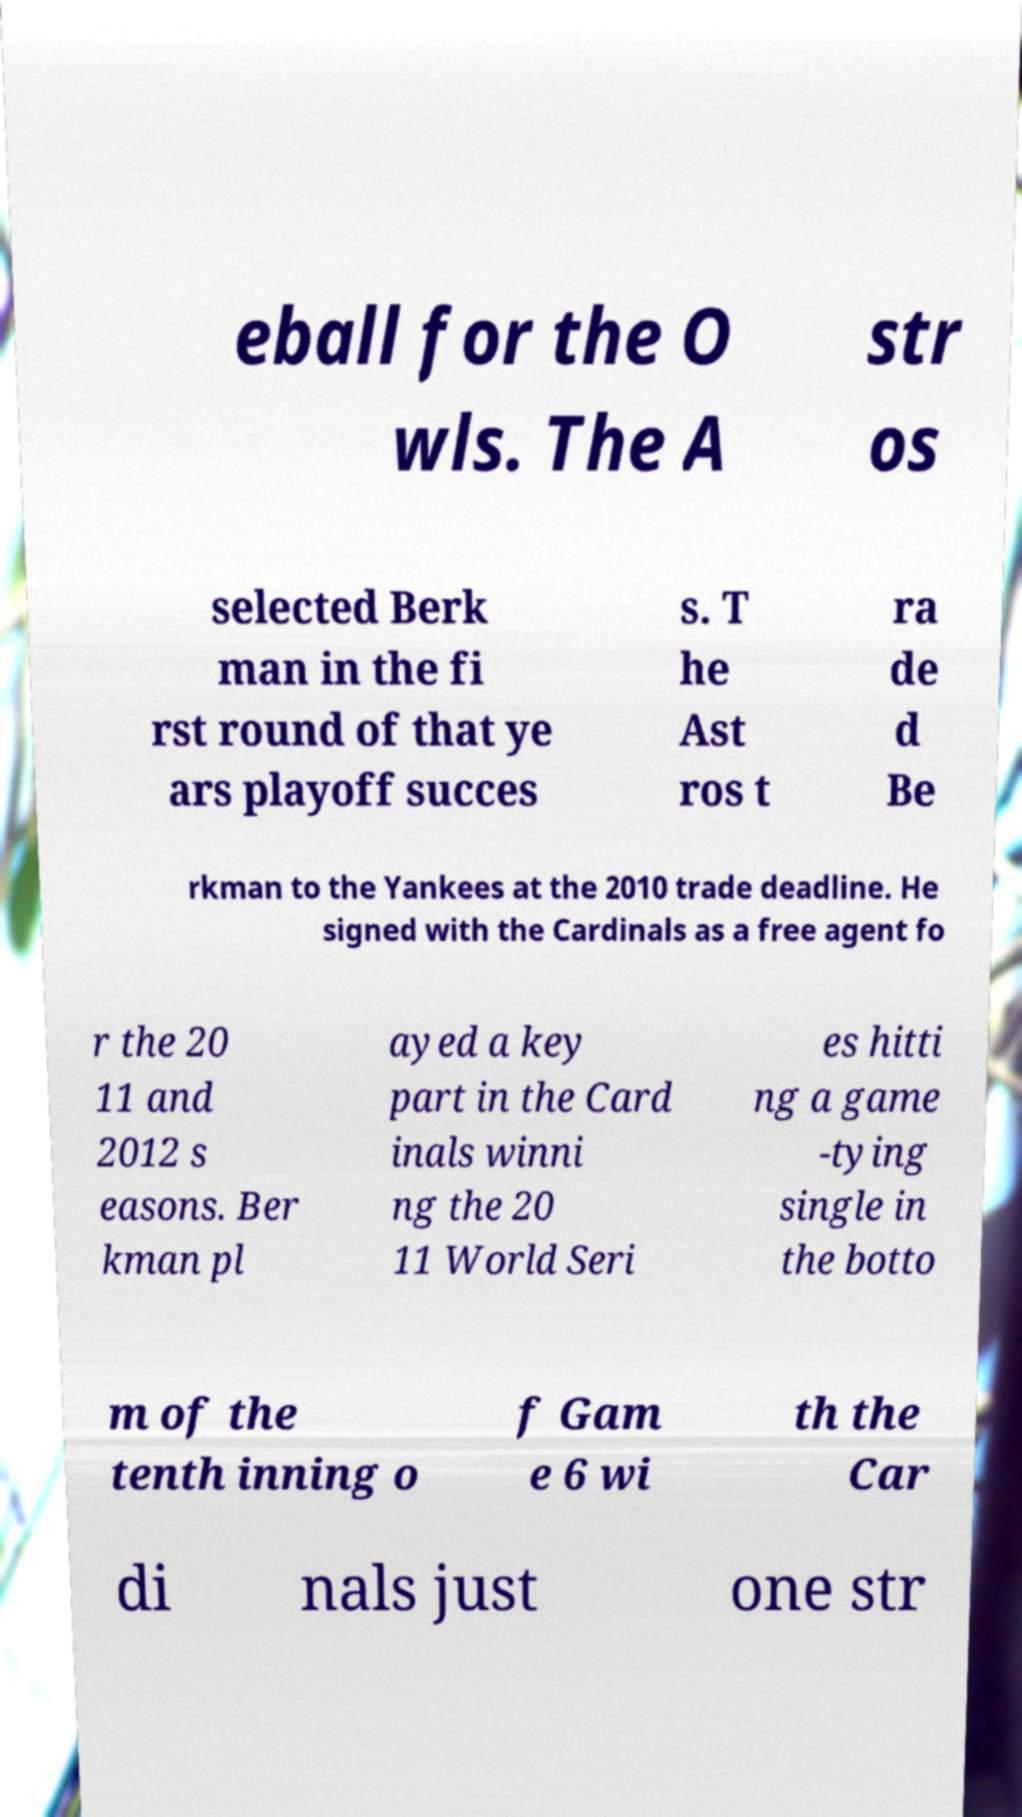Please identify and transcribe the text found in this image. eball for the O wls. The A str os selected Berk man in the fi rst round of that ye ars playoff succes s. T he Ast ros t ra de d Be rkman to the Yankees at the 2010 trade deadline. He signed with the Cardinals as a free agent fo r the 20 11 and 2012 s easons. Ber kman pl ayed a key part in the Card inals winni ng the 20 11 World Seri es hitti ng a game -tying single in the botto m of the tenth inning o f Gam e 6 wi th the Car di nals just one str 